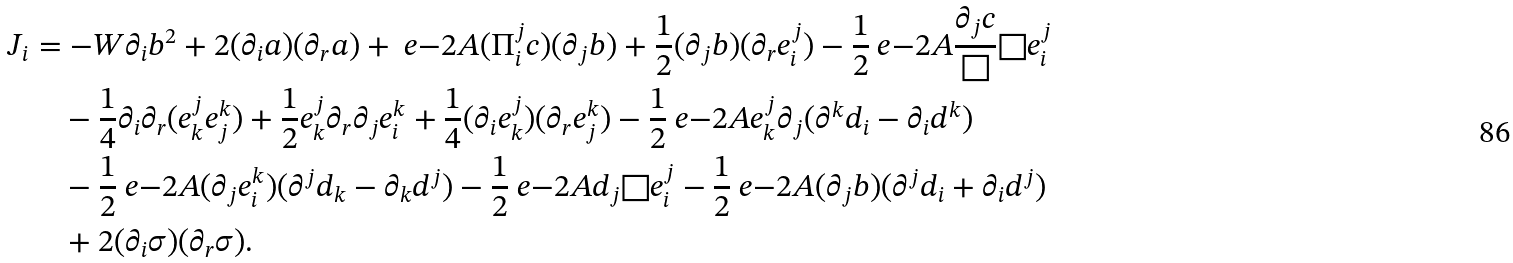<formula> <loc_0><loc_0><loc_500><loc_500>J _ { i } & = - W \partial _ { i } b ^ { 2 } + 2 ( \partial _ { i } a ) ( \partial _ { r } a ) + \ e { - 2 A } ( \Pi ^ { j } _ { i } c ) ( \partial _ { j } b ) + \frac { 1 } { 2 } ( \partial _ { j } b ) ( \partial _ { r } e ^ { j } _ { i } ) - \frac { 1 } { 2 } \ e { - 2 A } \frac { \partial _ { j } c } { \Box } \Box e ^ { j } _ { i } \\ & \quad - \frac { 1 } { 4 } \partial _ { i } \partial _ { r } ( e ^ { j } _ { k } e ^ { k } _ { j } ) + \frac { 1 } { 2 } e ^ { j } _ { k } \partial _ { r } \partial _ { j } e ^ { k } _ { i } + \frac { 1 } { 4 } ( \partial _ { i } e ^ { j } _ { k } ) ( \partial _ { r } e ^ { k } _ { j } ) - \frac { 1 } { 2 } \ e { - 2 A } e ^ { j } _ { k } \partial _ { j } ( \partial ^ { k } d _ { i } - \partial _ { i } d ^ { k } ) \\ & \quad - \frac { 1 } { 2 } \ e { - 2 A } ( \partial _ { j } e ^ { k } _ { i } ) ( \partial ^ { j } d _ { k } - \partial _ { k } d ^ { j } ) - \frac { 1 } { 2 } \ e { - 2 A } d _ { j } \Box e ^ { j } _ { i } - \frac { 1 } { 2 } \ e { - 2 A } ( \partial _ { j } b ) ( \partial ^ { j } d _ { i } + \partial _ { i } d ^ { j } ) \\ & \quad + 2 ( \partial _ { i } \sigma ) ( \partial _ { r } \sigma ) .</formula> 